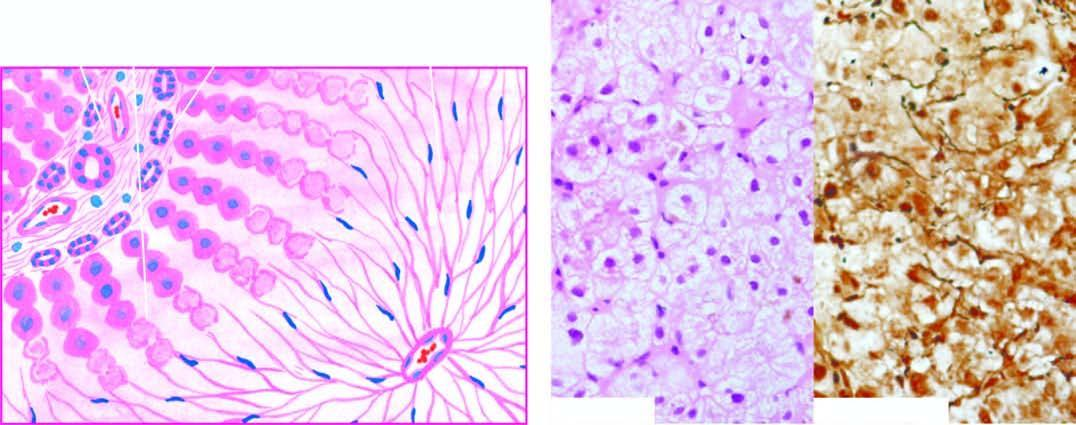what is there left out in their place, high lighted by reticulin stain right photomicrograph?
Answer the question using a single word or phrase. Wiping out of liver lobules with only collapsed reticulin framework 